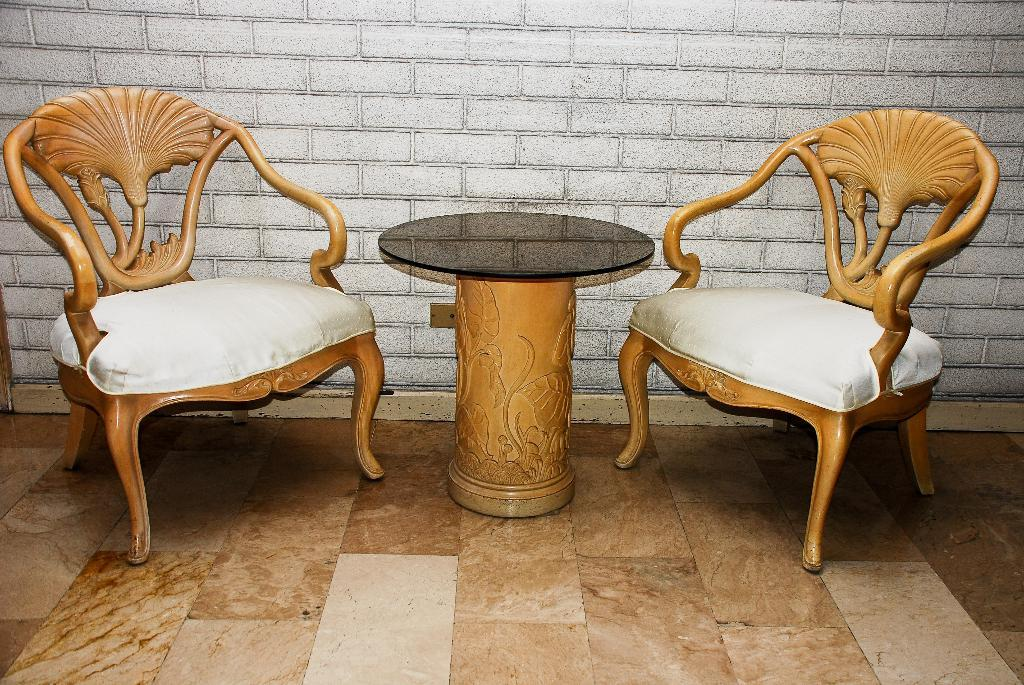Where was the image taken? The image was taken inside a room. What furniture can be seen in the center of the image? There are wooden chairs in the center of the image. What is placed on the ground in the image? A table is placed on the ground in the image. What type of wall is visible in the background of the image? There is a brick wall visible in the background of the image. Can you see any cows fighting with sticks in the image? No, there are no cows or sticks present in the image. 